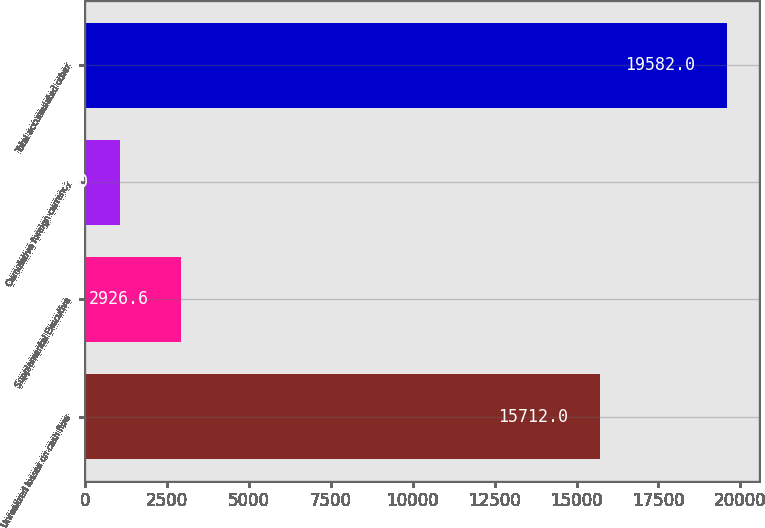Convert chart. <chart><loc_0><loc_0><loc_500><loc_500><bar_chart><fcel>Unrealized losses on cash flow<fcel>Supplemental Executive<fcel>Cumulative foreign currency<fcel>Total accumulated other<nl><fcel>15712<fcel>2926.6<fcel>1076<fcel>19582<nl></chart> 